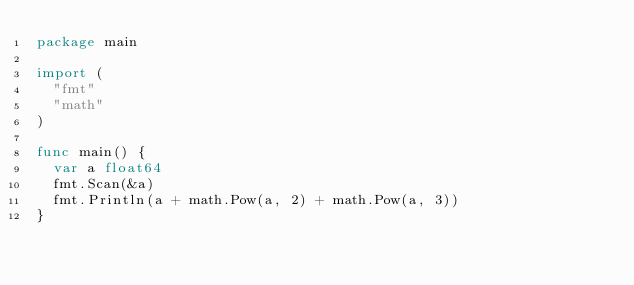<code> <loc_0><loc_0><loc_500><loc_500><_Go_>package main

import (
	"fmt"
	"math"
)

func main() {
	var a float64
	fmt.Scan(&a)
	fmt.Println(a + math.Pow(a, 2) + math.Pow(a, 3))
}
</code> 